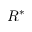Convert formula to latex. <formula><loc_0><loc_0><loc_500><loc_500>R ^ { * }</formula> 